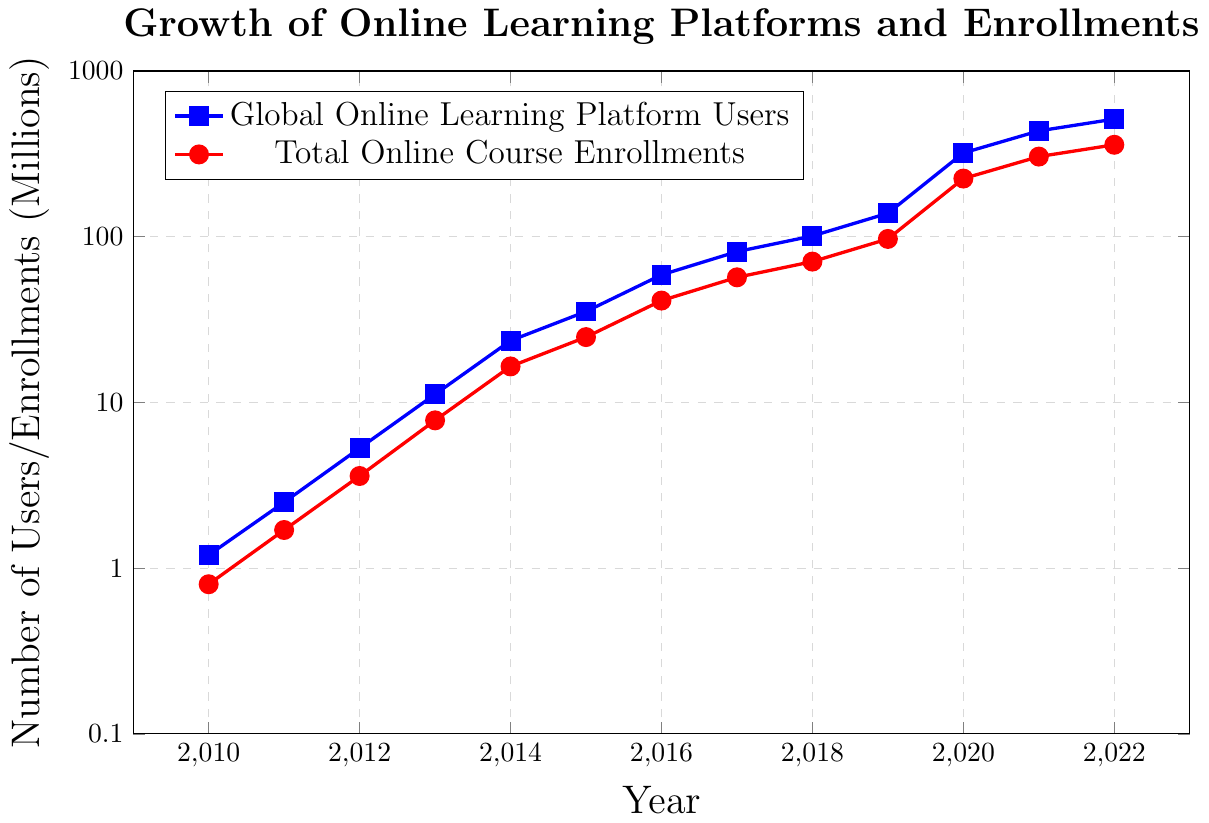What was the number of Global Online Learning Platform Users in 2017? To find the number of Global Online Learning Platform Users in 2017, locate the corresponding value in the blue plot at the year 2017.
Answer: 81.3 million How much did the Total Online Course Enrollments increase from 2010 to 2020? Subtract the value of Total Online Course Enrollments in 2010 from that in 2020. The values are 0.8 million (2010) and 224.4 million (2020). Hence, the increase is 224.4 - 0.8.
Answer: 223.6 million Between which two consecutive years was there the largest increase in Global Online Learning Platform Users? Compare the difference in the number of users year-over-year for each consecutive pair of years.
Answer: 2019 to 2020 By what factor did Global Online Learning Platform Users grow from 2010 to 2022? Divide the number of users in 2022 by the number of users in 2010. The values are 512.8 million (2022) and 1.2 million (2010).
Answer: Approximately 427 What trend can be observed in the gap between Global Online Learning Platform Users and Total Online Course Enrollments over the years? Observe the blue and red lines on the plot and note how the gap between them changes from year to year.
Answer: The gap increases over time Which year had the highest number of Total Online Course Enrollments? Identify the peak value in the red plot.
Answer: 2022 If the trend continues, estimate the number of Total Online Course Enrollments in 2023 based on the previous pattern. Observe the pattern of growth in Total Online Course Enrollments and extrapolate to 2023 considering recent exponential growth trends. An approximate estimation can be made by projecting the increase in the previous years.
Answer: Estimation needed, potentially around 400-450 million Did the Global Online Learning Platform Users ever double in a single year? If so, provide the year and value. Identify any year where the value was at least double the value of the previous year.
Answer: 2011 (2.5 million from 1.2 million in 2010) 